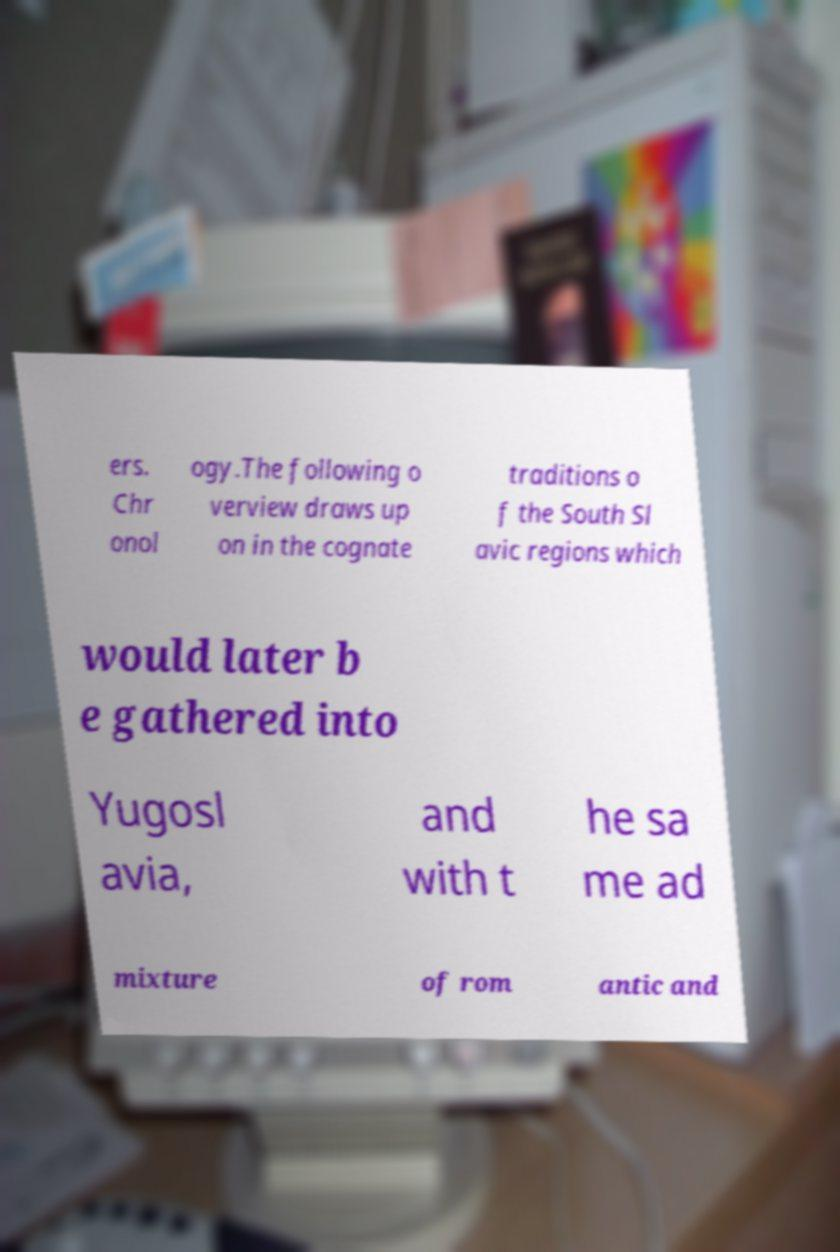What messages or text are displayed in this image? I need them in a readable, typed format. ers. Chr onol ogy.The following o verview draws up on in the cognate traditions o f the South Sl avic regions which would later b e gathered into Yugosl avia, and with t he sa me ad mixture of rom antic and 